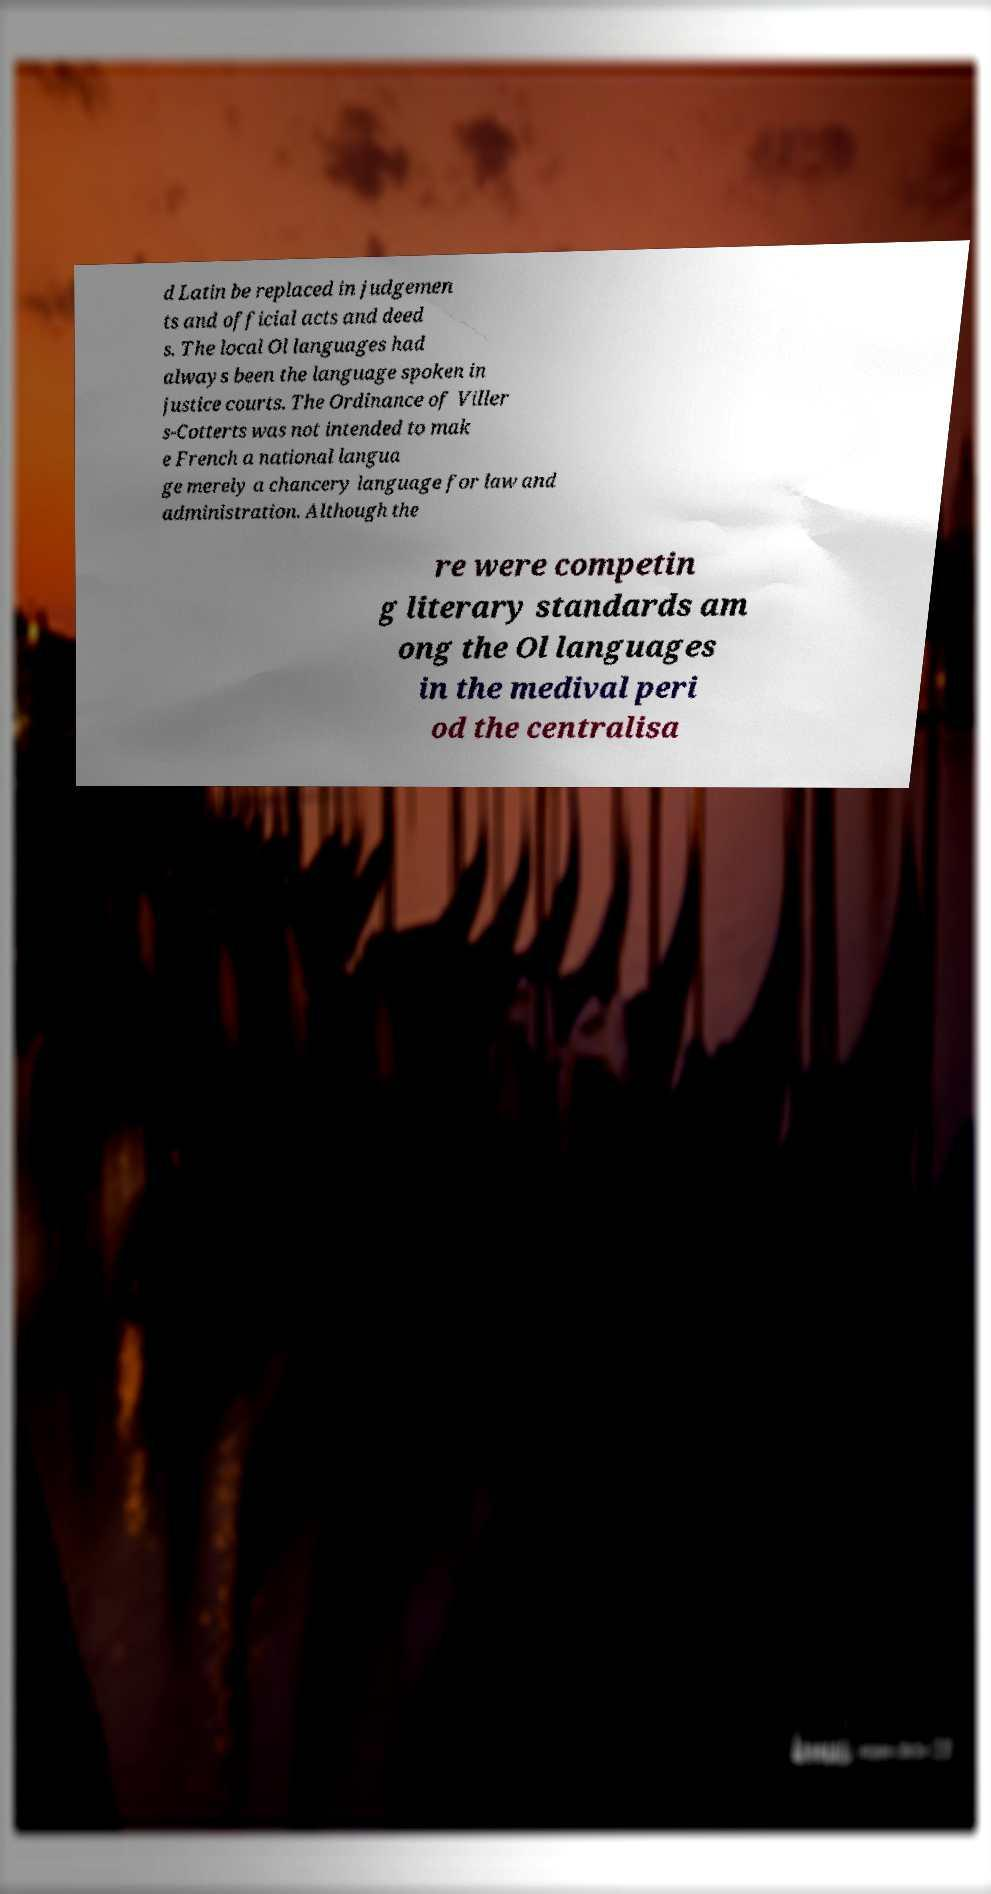I need the written content from this picture converted into text. Can you do that? d Latin be replaced in judgemen ts and official acts and deed s. The local Ol languages had always been the language spoken in justice courts. The Ordinance of Viller s-Cotterts was not intended to mak e French a national langua ge merely a chancery language for law and administration. Although the re were competin g literary standards am ong the Ol languages in the medival peri od the centralisa 